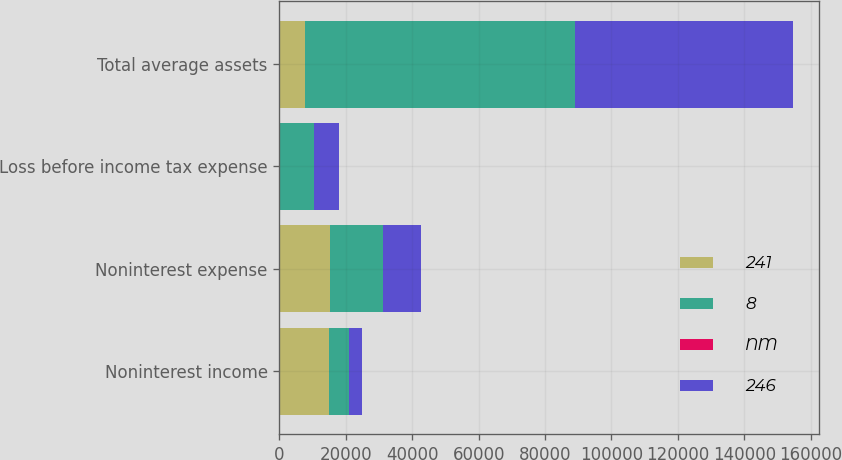Convert chart. <chart><loc_0><loc_0><loc_500><loc_500><stacked_bar_chart><ecel><fcel>Noninterest income<fcel>Noninterest expense<fcel>Loss before income tax expense<fcel>Total average assets<nl><fcel>241<fcel>14798<fcel>15113<fcel>69<fcel>7602<nl><fcel>8<fcel>6078<fcel>16071<fcel>10234<fcel>81312<nl><fcel>NM<fcel>143.5<fcel>6<fcel>99.3<fcel>15<nl><fcel>246<fcel>3961<fcel>11555<fcel>7602<fcel>65733<nl></chart> 